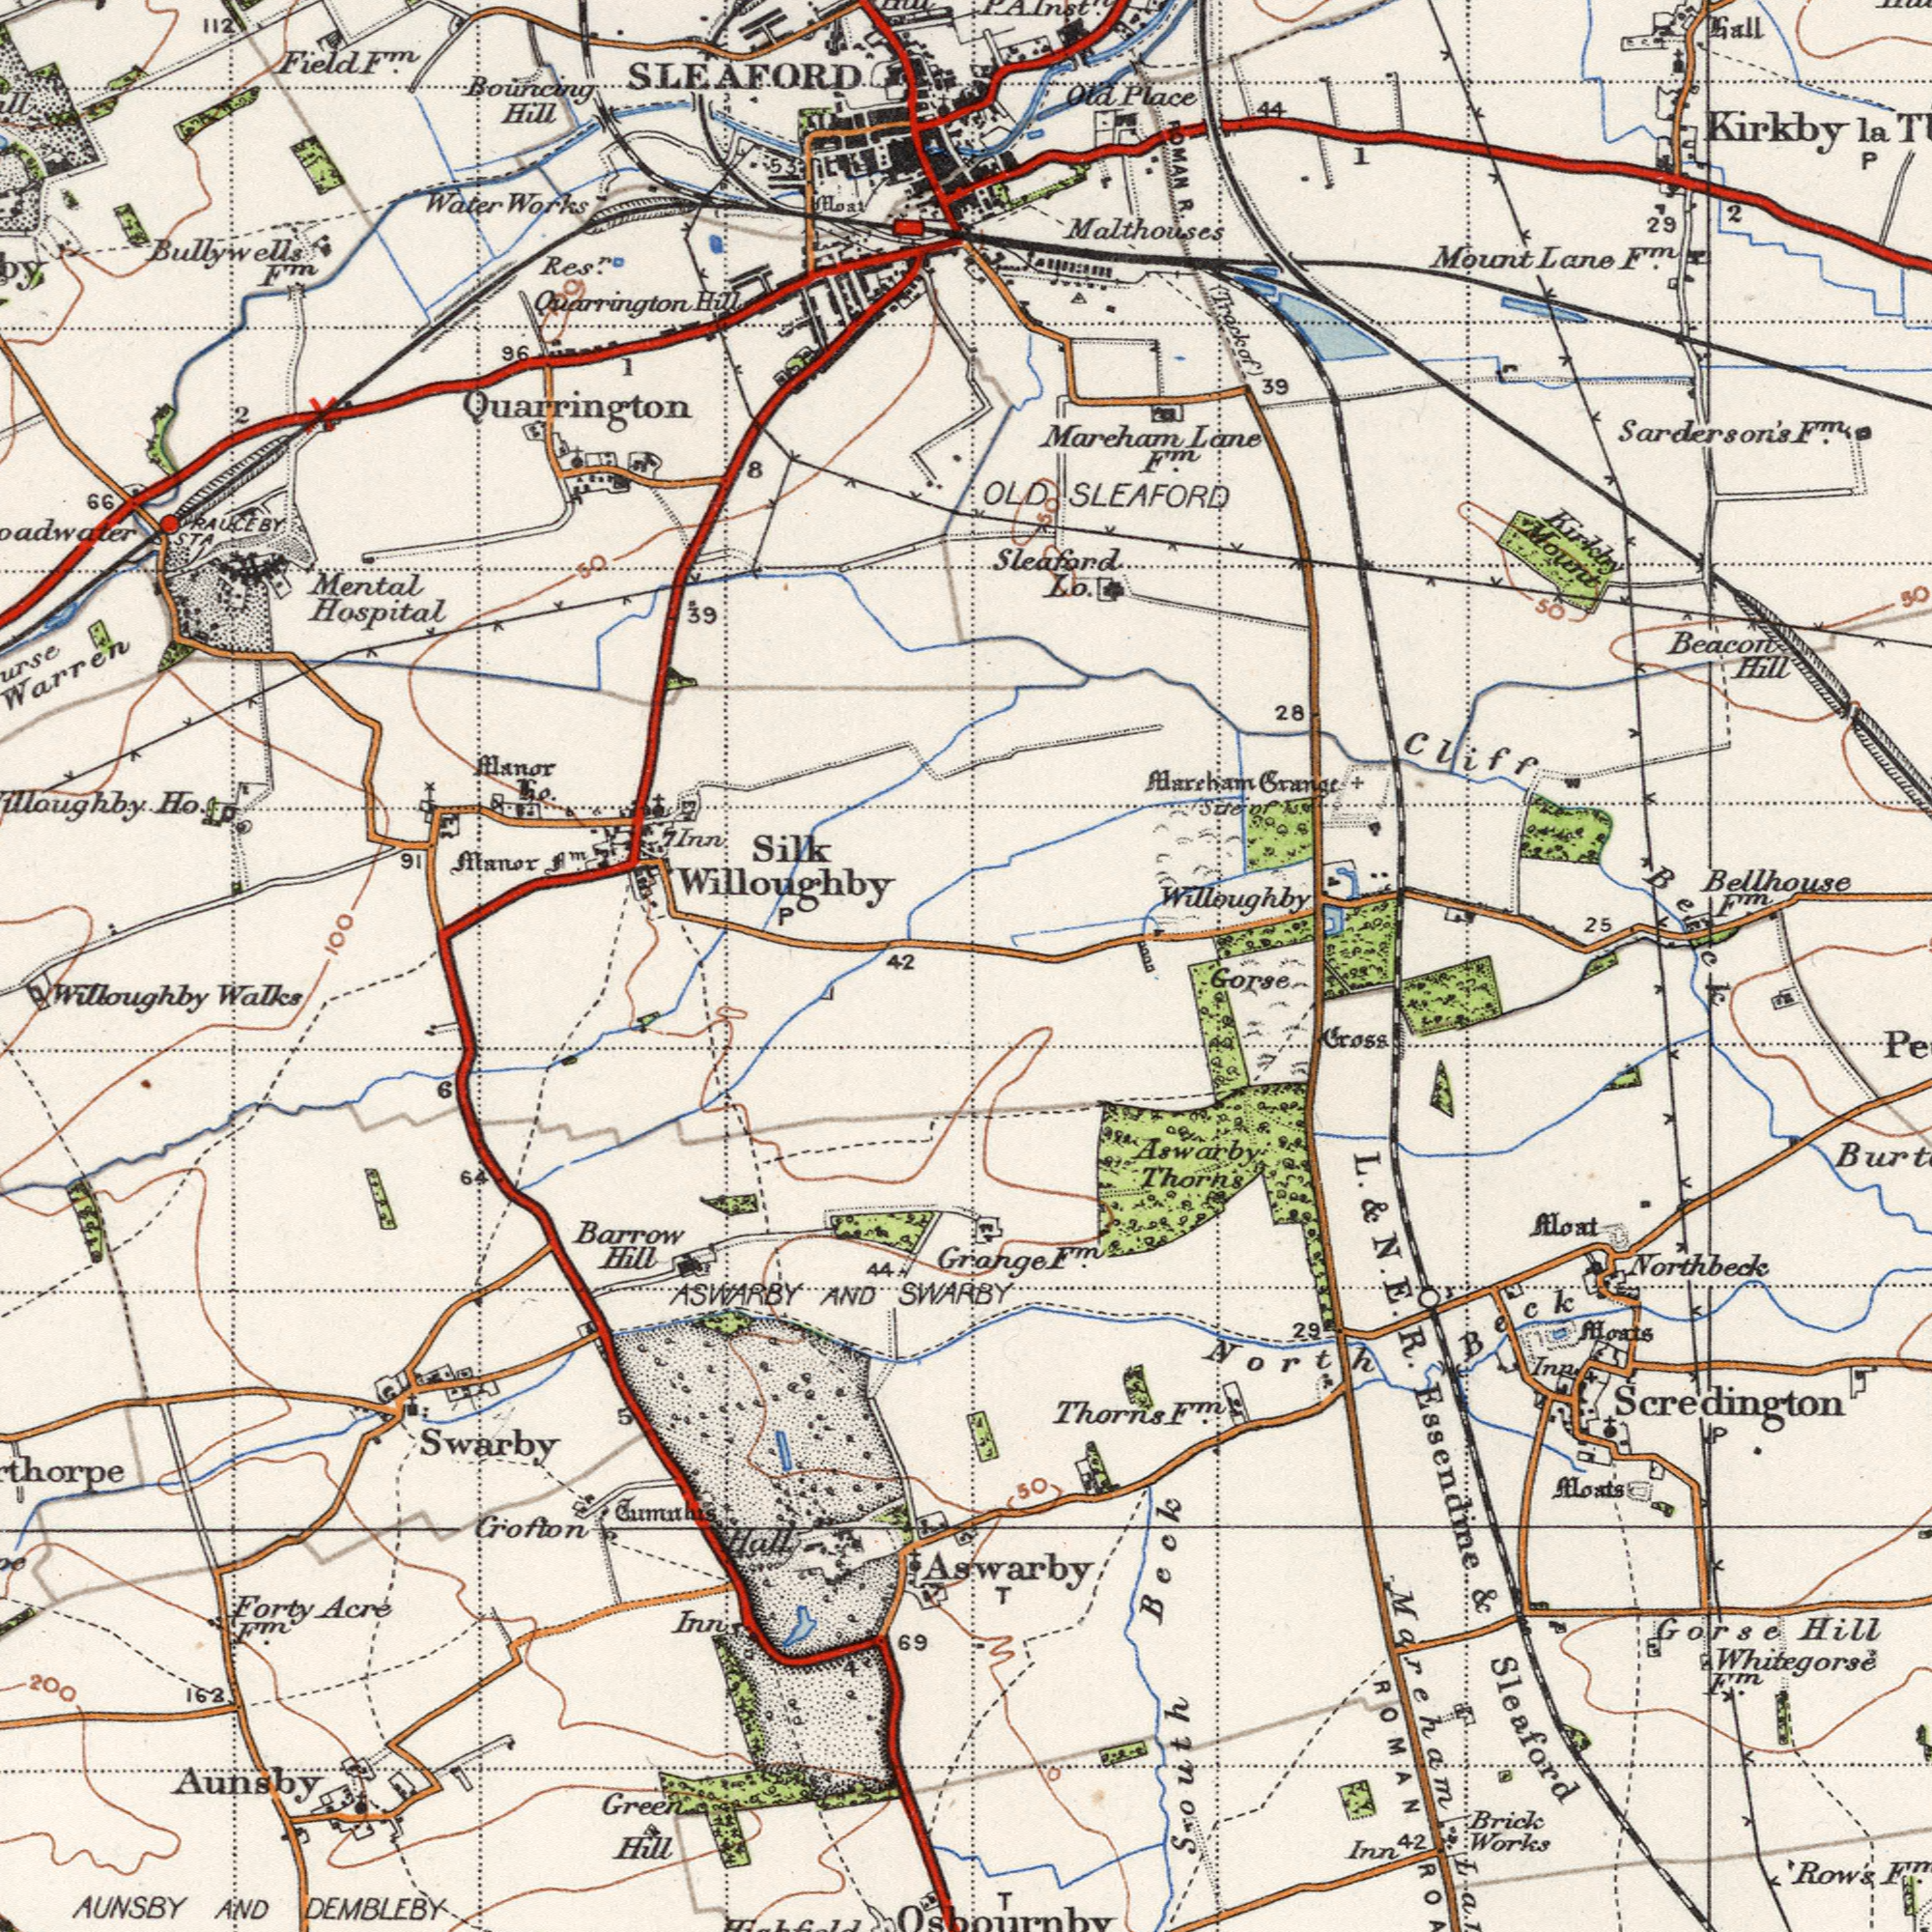What text is visible in the upper-left corner? Hospital Silk Water Hill Mental Works Manor Bouncing Quarrington 39 Quarrington 66 Elanor 112 91 Willoughby Field 96 Hill Bullywells 8 2 RAUCEBY F<sup>m</sup>. To. Aloat SLEAFORD 1 P Res<sup>r</sup>. Ho. 7Inn 50 STA F<sup>m</sup>. 53 100 f<sup>m</sup>. 42 100 What text is visible in the lower-left corner? DEMBLEBY AUNSBY Aunsby Green SWARBY Willoughby Barrow Grofton ASWARBY AND Forty AND Walks Swarby Hill Inns Hill Acre 69 163 Cumuhis 64 6 F<sup>m</sup>. Hall 44 200 What text appears in the bottom-right area of the image? Sleaford South Scredington Beck L. R. Works Row's Hill Essendine Aswarby Northbeck Brick Gorse Moat Inn Moats 50 North Whitegorse Thorns Aswarby Gross F<sup>m</sup>. T Thorns 29 Mareham Inn & Gorse E. T F<sup>m</sup>. 42 Grange F<sup>m</sup>. Moats Beck ROMAN P & F<sup>m</sup>. Osbournby N. What text is shown in the top-right quadrant? Sarderson's Bellhouse Mount Mareham Cliff Malthouses Lane Beacon 44 25 Place Kirkby Lane Trackof Grange 2 Hill OLD Gall 28 la Old Alarcham Kirkby 50 Mount 1 39 R. 29 F<sup>m</sup>. SLEAFORD F<sup>m</sup>. Sleaford P Willoughby Site F<sup>m</sup>. 50 F<sup>m</sup>. Lo. ROMAN P. A. Inst<sup>n</sup>. Beck of 50 